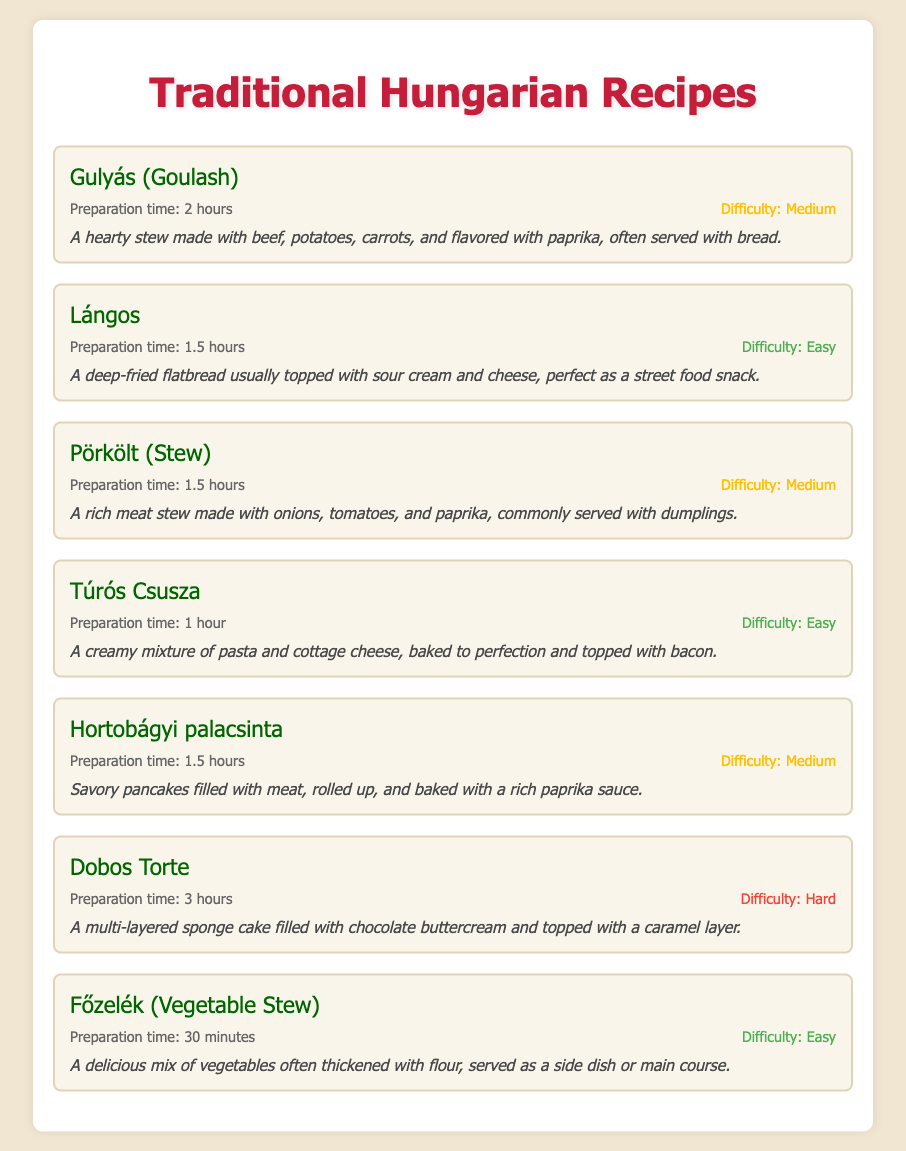What is the preparation time for Gulyás? The preparation time for Gulyás is listed as 2 hours in the document.
Answer: 2 hours Which recipe has the highest difficulty level? The recipe with the highest difficulty level is Dobos Torte, which is classified as Hard.
Answer: Dobos Torte How long does it take to prepare Főzelék? The document states that Főzelék has a preparation time of 30 minutes.
Answer: 30 minutes What is the main ingredient in Lángos? Lángos is typically made from a deep-fried flatbread, which is the focus of the recipe.
Answer: Flatbread Which recipe is described as a hearty stew? The recipe described as a hearty stew is Gulyás (Goulash).
Answer: Gulyás (Goulash) What is the preparation time for Dobos Torte? The document specifies that the preparation time for Dobos Torte is 3 hours.
Answer: 3 hours How many recipes listed are classified as easy? The document lists three recipes that are classified as easy: Lángos, Túrós Csusza, and Főzelék.
Answer: 3 Which recipe involves pancakes and meat? The recipe involving pancakes and meat is Hortonágyi palacsinta.
Answer: Hortobágyi palacsinta What is Pörkölt commonly served with? Pörkölt is commonly served with dumplings, according to the description.
Answer: Dumplings 